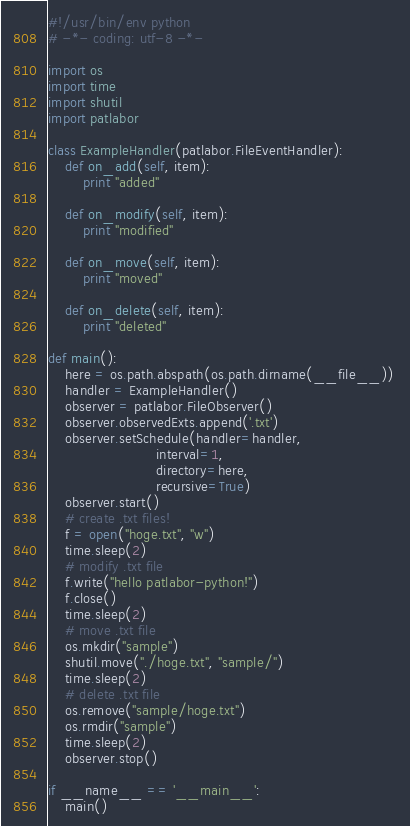<code> <loc_0><loc_0><loc_500><loc_500><_Python_>#!/usr/bin/env python
# -*- coding: utf-8 -*-

import os
import time
import shutil
import patlabor

class ExampleHandler(patlabor.FileEventHandler):
	def on_add(self, item):
		print "added"

	def on_modify(self, item):
		print "modified"

	def on_move(self, item):
		print "moved"

	def on_delete(self, item):
		print "deleted"

def main():
	here = os.path.abspath(os.path.dirname(__file__)) 
	handler = ExampleHandler()
	observer = patlabor.FileObserver()
	observer.observedExts.append('.txt')
	observer.setSchedule(handler=handler,
						 interval=1,
						 directory=here,
						 recursive=True)
	observer.start()
	# create .txt files!
	f = open("hoge.txt", "w")
	time.sleep(2)
	# modify .txt file
	f.write("hello patlabor-python!")
	f.close()
	time.sleep(2)	
	# move .txt file
	os.mkdir("sample")
	shutil.move("./hoge.txt", "sample/")
	time.sleep(2)
	# delete .txt file
	os.remove("sample/hoge.txt")
	os.rmdir("sample")
	time.sleep(2)
	observer.stop()		

if __name__ == '__main__':
	main()</code> 